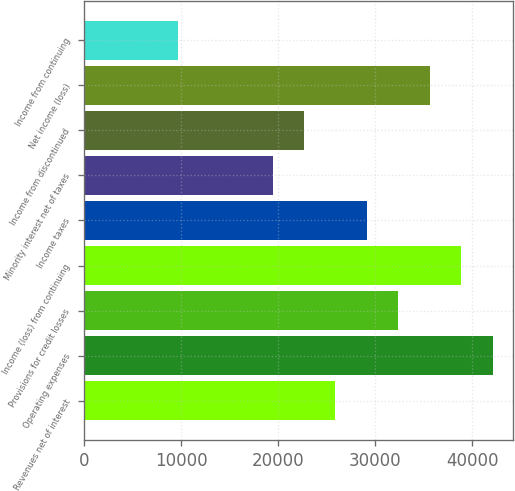<chart> <loc_0><loc_0><loc_500><loc_500><bar_chart><fcel>Revenues net of interest<fcel>Operating expenses<fcel>Provisions for credit losses<fcel>Income (loss) from continuing<fcel>Income taxes<fcel>Minority interest net of taxes<fcel>Income from discontinued<fcel>Net income (loss)<fcel>Income from continuing<nl><fcel>25912<fcel>42106.9<fcel>32390<fcel>38867.9<fcel>29151<fcel>19434<fcel>22673<fcel>35628.9<fcel>9717.1<nl></chart> 